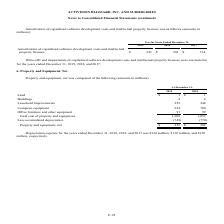According to Activision Blizzard's financial document, What was the depreciation expense for 2017? Based on the financial document, the answer is $130 million (in millions). Also, What was the depreciation expense for 2019? According to the financial document, $124 million (in millions). The relevant text states: "years ended December 31, 2019, 2018, and 2017 was $124 million, $138 million, and $130..." Also, What was the net cost of Land in 2019? According to the financial document, $1 (in millions). The relevant text states: "For the Years Ended December 31,..." Also, can you calculate: What was the change in the net cost of computer equipment between 2018 and 2019? Based on the calculation: 654-700, the result is -46 (in millions). This is based on the information: "Computer equipment 654 700 Computer equipment 654 700..." The key data points involved are: 654, 700. Also, can you calculate: What was the change in the property and equipment, net between 2018 and 2019? Based on the calculation: 253-282, the result is -29 (in millions). This is based on the information: "Property and equipment, net $ 253 $ 282 Property and equipment, net $ 253 $ 282..." The key data points involved are: 253, 282. Also, can you calculate: What was the percentage change in total cost of property and equipment between 2018 and 2019? To answer this question, I need to perform calculations using the financial data. The calculation is: (1,002-1,052)/1,052, which equals -4.75 (percentage). This is based on the information: "Total cost of property and equipment 1,002 1,052 Total cost of property and equipment 1,002 1,052..." The key data points involved are: 1,002, 1,052. 